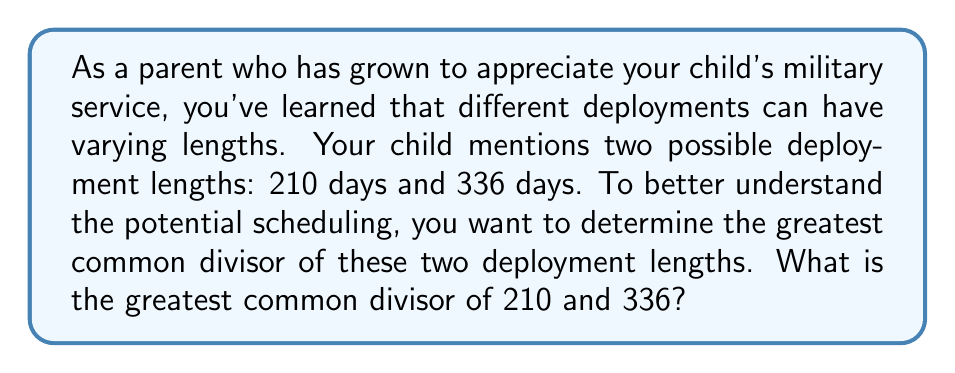Give your solution to this math problem. To find the greatest common divisor (GCD) of 210 and 336, we'll use the Euclidean algorithm:

1) First, divide 336 by 210:
   $336 = 1 \times 210 + 126$

2) Now divide 210 by 126:
   $210 = 1 \times 126 + 84$

3) Divide 126 by 84:
   $126 = 1 \times 84 + 42$

4) Divide 84 by 42:
   $84 = 2 \times 42 + 0$

The process stops when we get a remainder of 0. The last non-zero remainder is the GCD.

Therefore, $GCD(210, 336) = 42$

We can verify this result:
$210 = 5 \times 42$
$336 = 8 \times 42$

This means that both deployment lengths are divisible by 42 days, which could represent 6 weeks. This common factor might be useful for planning purposes or understanding potential rotation schedules.
Answer: The greatest common divisor of 210 and 336 is 42. 